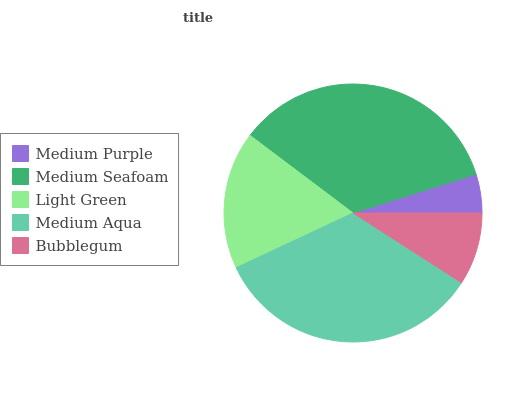Is Medium Purple the minimum?
Answer yes or no. Yes. Is Medium Seafoam the maximum?
Answer yes or no. Yes. Is Light Green the minimum?
Answer yes or no. No. Is Light Green the maximum?
Answer yes or no. No. Is Medium Seafoam greater than Light Green?
Answer yes or no. Yes. Is Light Green less than Medium Seafoam?
Answer yes or no. Yes. Is Light Green greater than Medium Seafoam?
Answer yes or no. No. Is Medium Seafoam less than Light Green?
Answer yes or no. No. Is Light Green the high median?
Answer yes or no. Yes. Is Light Green the low median?
Answer yes or no. Yes. Is Medium Seafoam the high median?
Answer yes or no. No. Is Medium Seafoam the low median?
Answer yes or no. No. 